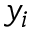<formula> <loc_0><loc_0><loc_500><loc_500>y _ { i }</formula> 